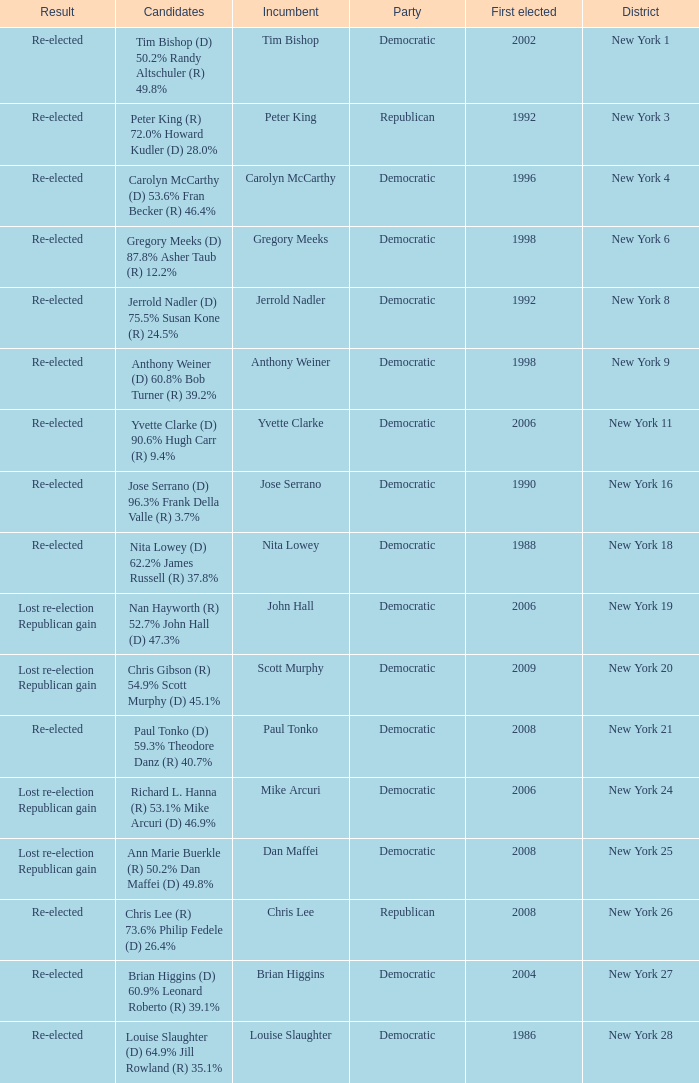Name the number of party for richard l. hanna (r) 53.1% mike arcuri (d) 46.9% 1.0. 